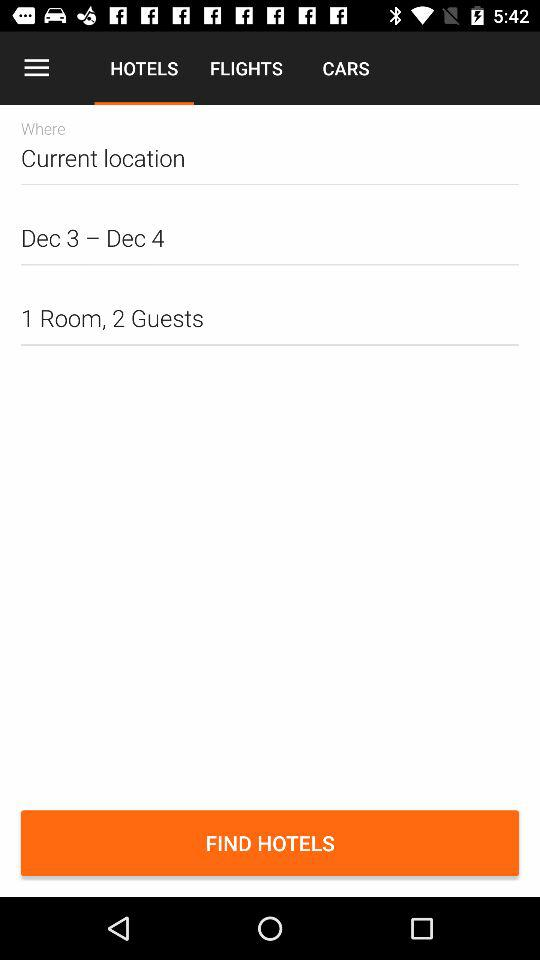What is the check-in date? The check-in date is December 3. 